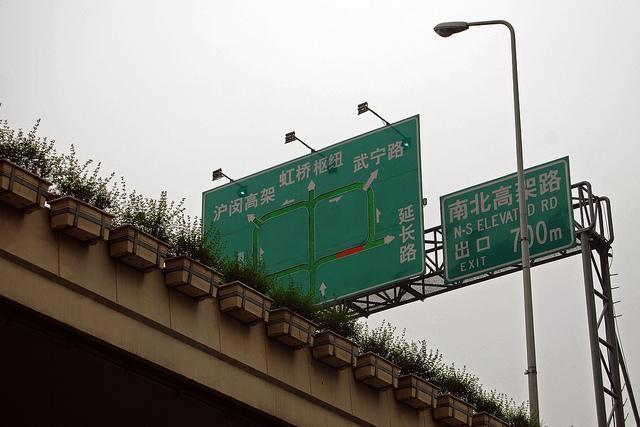According to the evidence up above where might you find the cameraman?
Indicate the correct choice and explain in the format: 'Answer: answer
Rationale: rationale.'
Options: China, south africa, america, india. Answer: china.
Rationale: Chinese text is shown on the signs. 